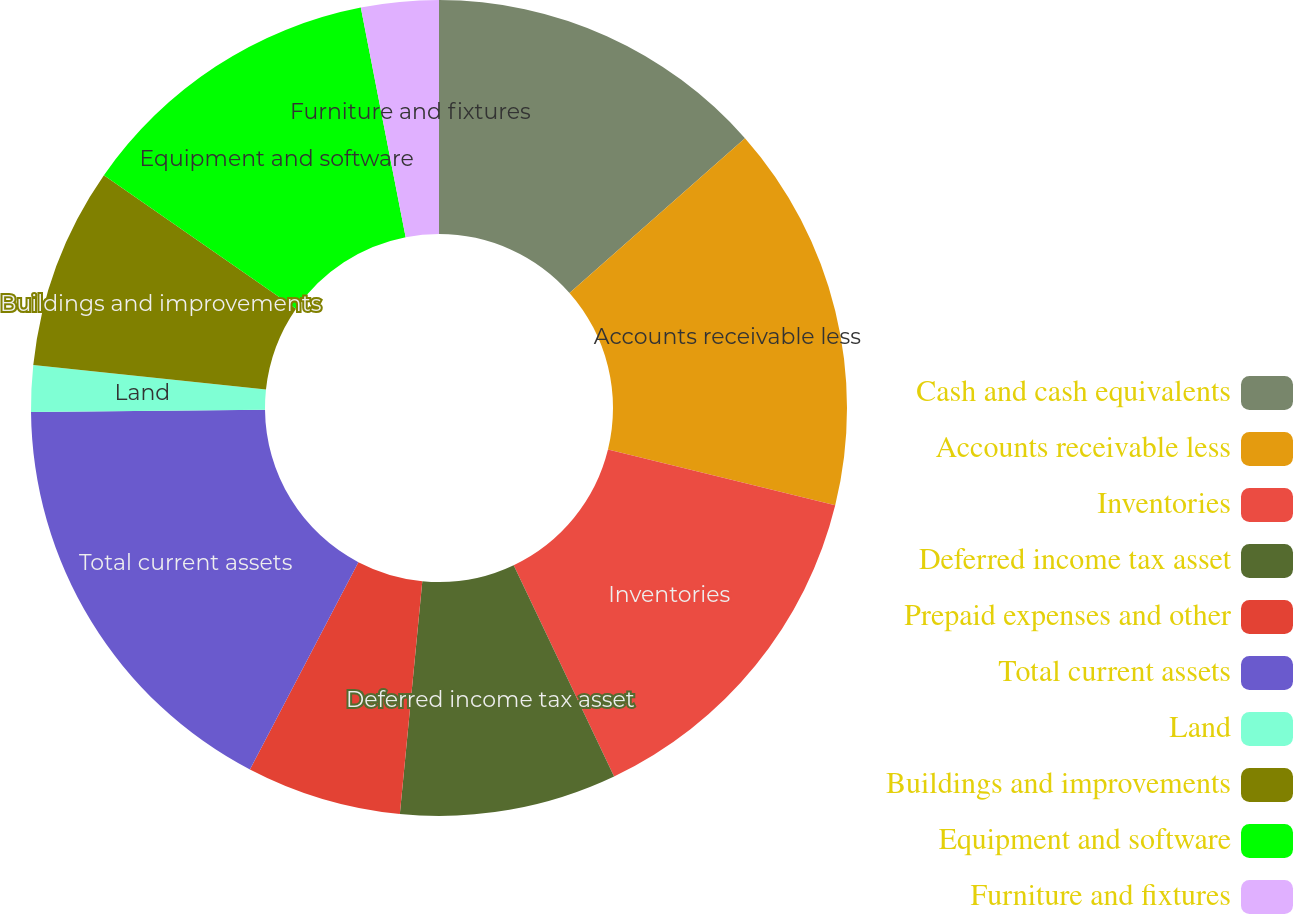<chart> <loc_0><loc_0><loc_500><loc_500><pie_chart><fcel>Cash and cash equivalents<fcel>Accounts receivable less<fcel>Inventories<fcel>Deferred income tax asset<fcel>Prepaid expenses and other<fcel>Total current assets<fcel>Land<fcel>Buildings and improvements<fcel>Equipment and software<fcel>Furniture and fixtures<nl><fcel>13.5%<fcel>15.34%<fcel>14.11%<fcel>8.59%<fcel>6.14%<fcel>17.18%<fcel>1.84%<fcel>7.98%<fcel>12.27%<fcel>3.07%<nl></chart> 